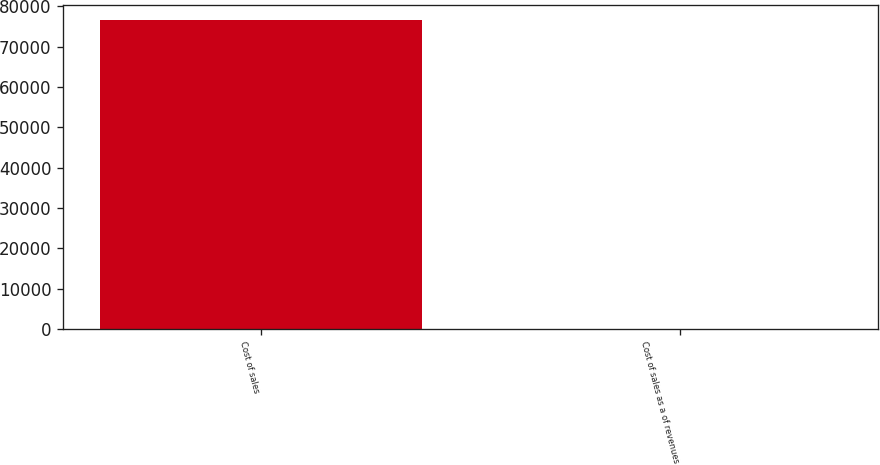Convert chart. <chart><loc_0><loc_0><loc_500><loc_500><bar_chart><fcel>Cost of sales<fcel>Cost of sales as a of revenues<nl><fcel>76612<fcel>81.5<nl></chart> 